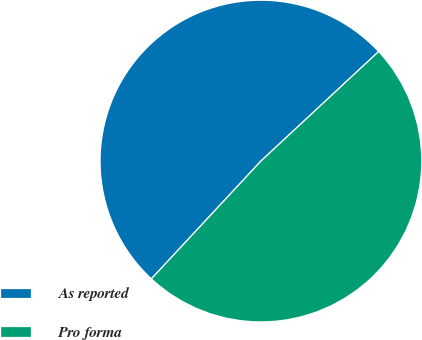Convert chart to OTSL. <chart><loc_0><loc_0><loc_500><loc_500><pie_chart><fcel>As reported<fcel>Pro forma<nl><fcel>51.15%<fcel>48.85%<nl></chart> 